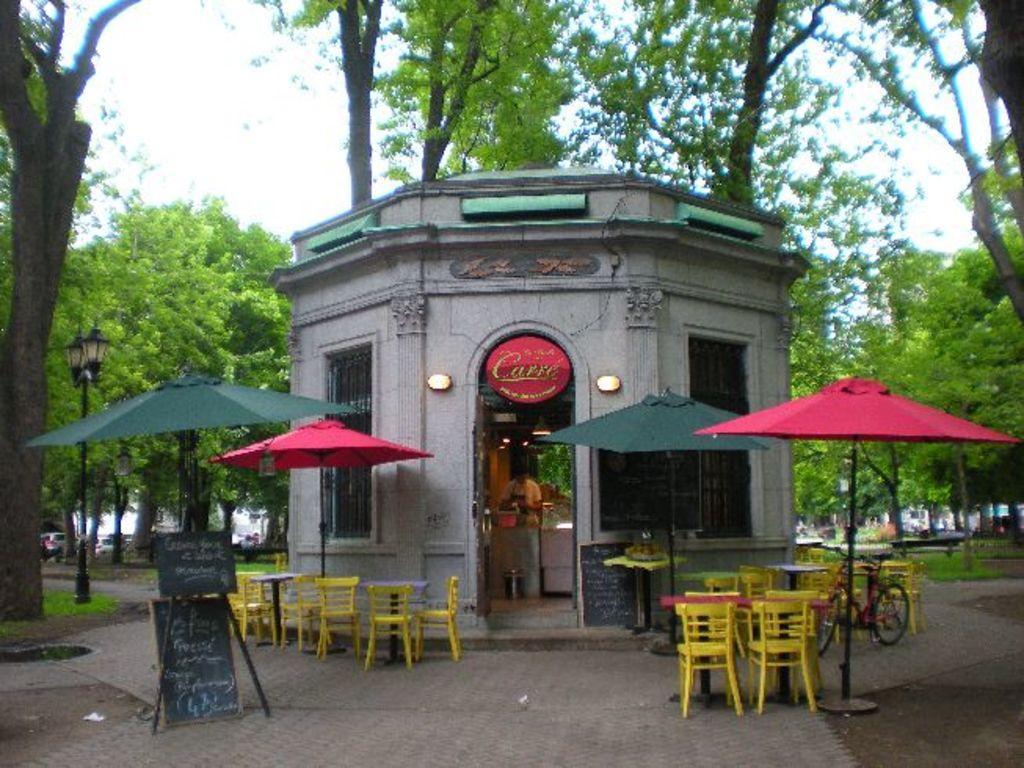Describe this image in one or two sentences. In the center of the image we can see a store. At the bottom there are parasols and boards. We can see chairs. On the right there is a bicycle. In the background there are trees, pole and sky. 